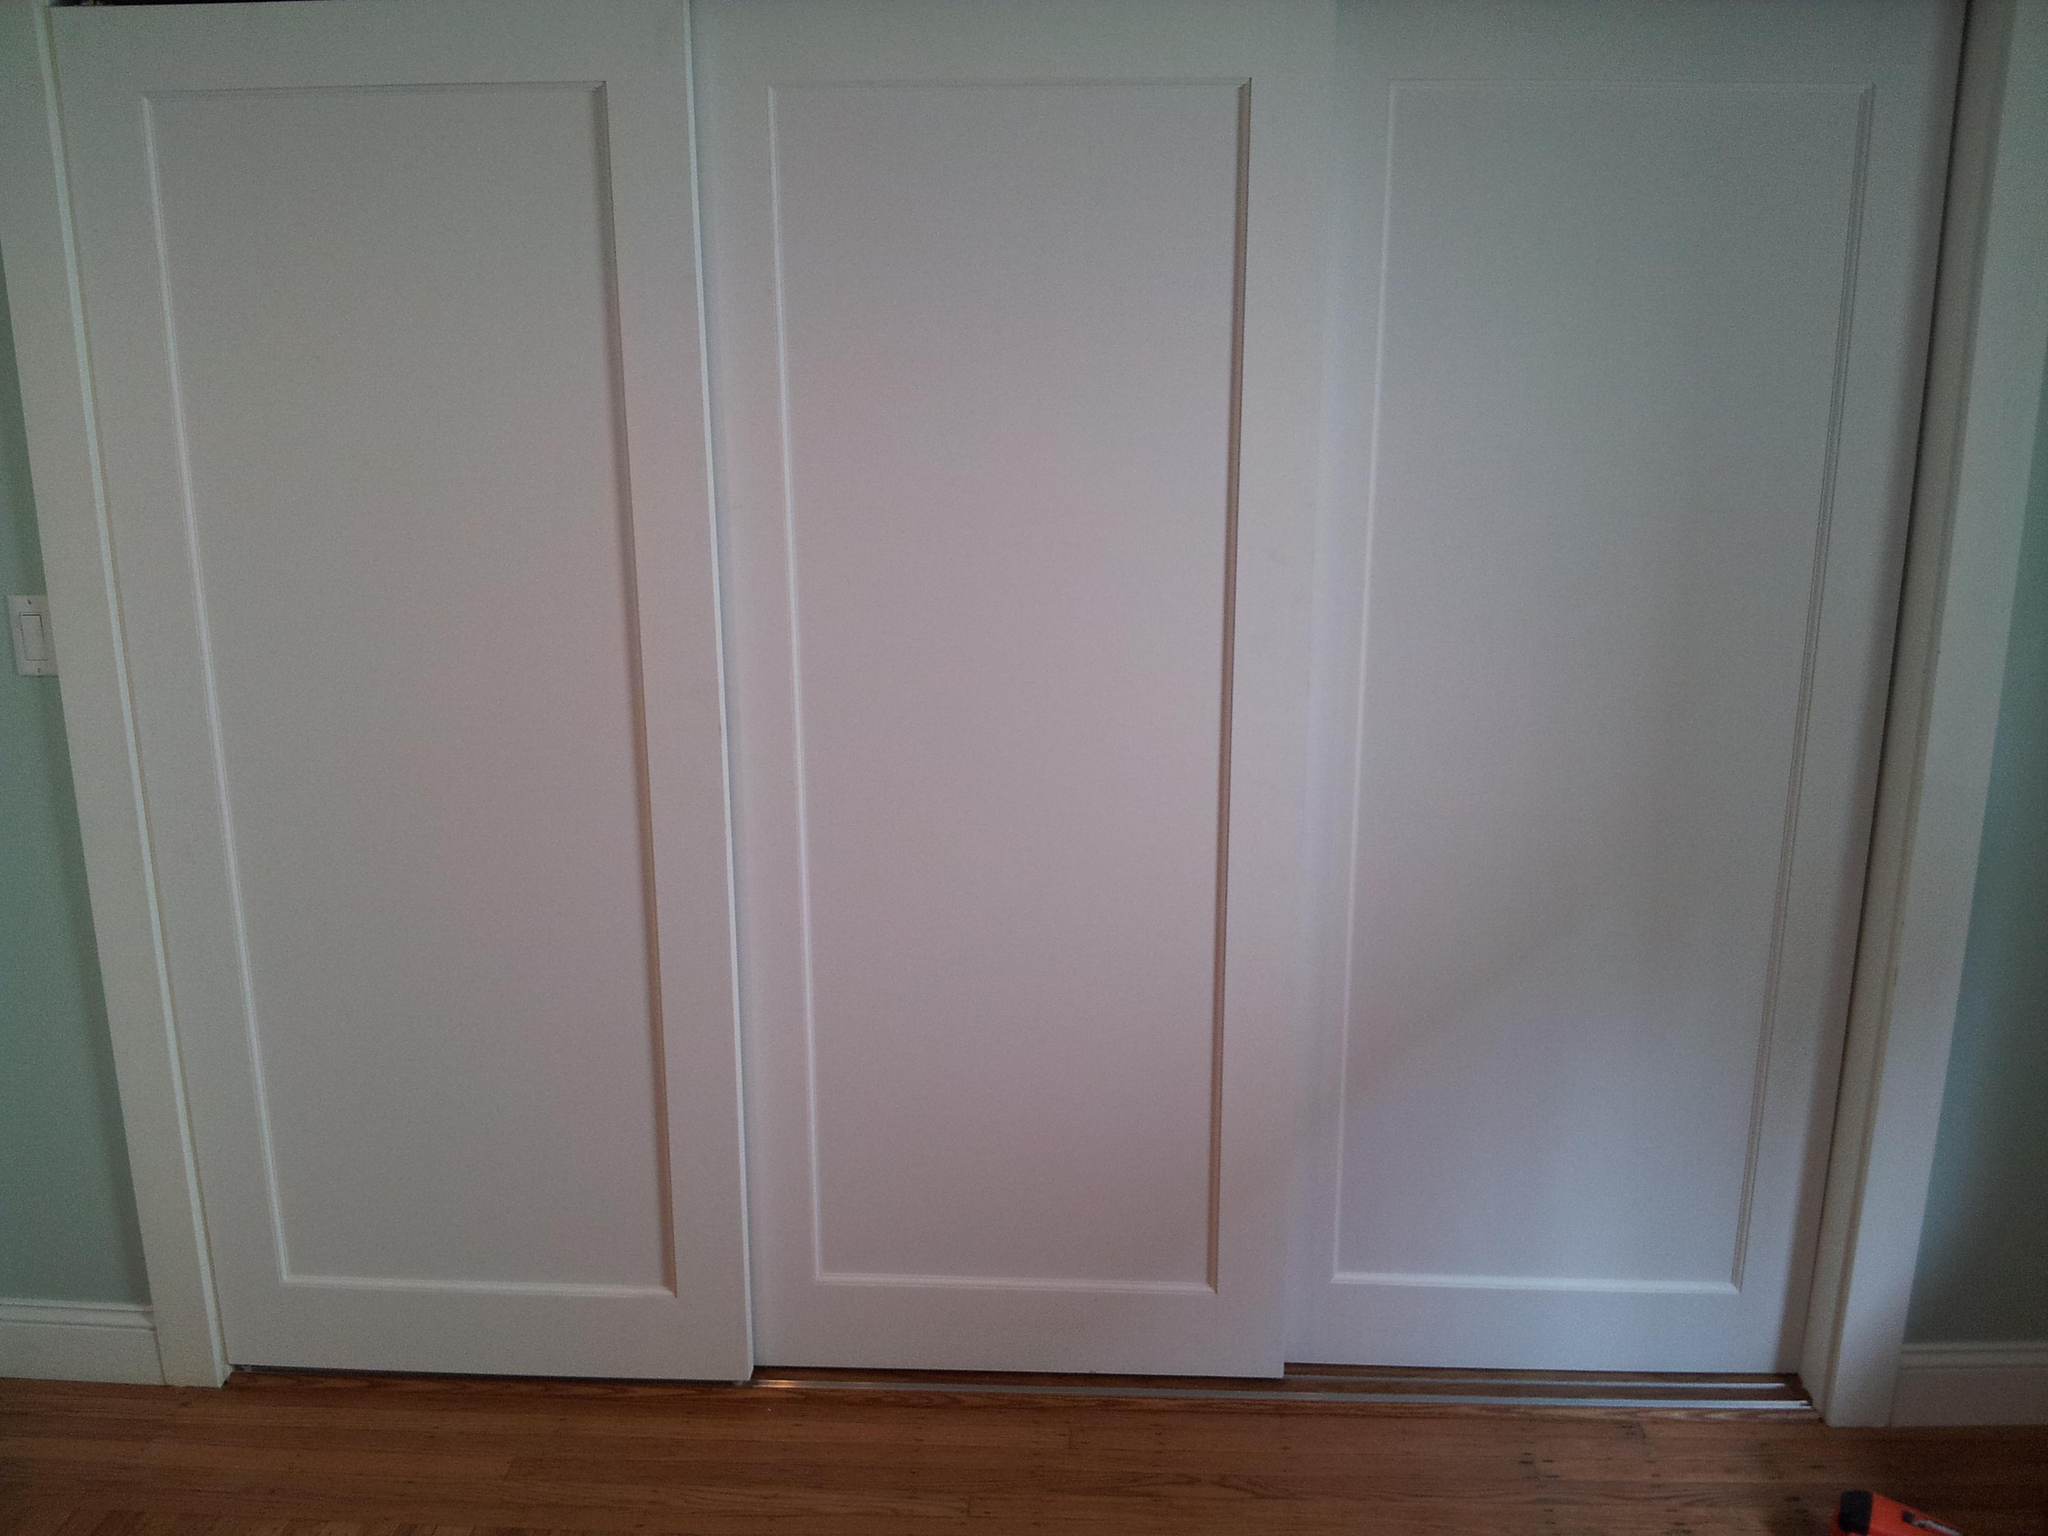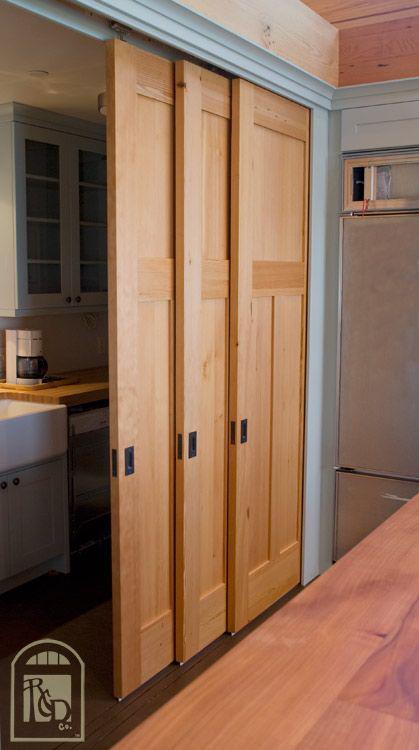The first image is the image on the left, the second image is the image on the right. Examine the images to the left and right. Is the description "An image shows tracks and three sliding glass doors with dark frames." accurate? Answer yes or no. No. 